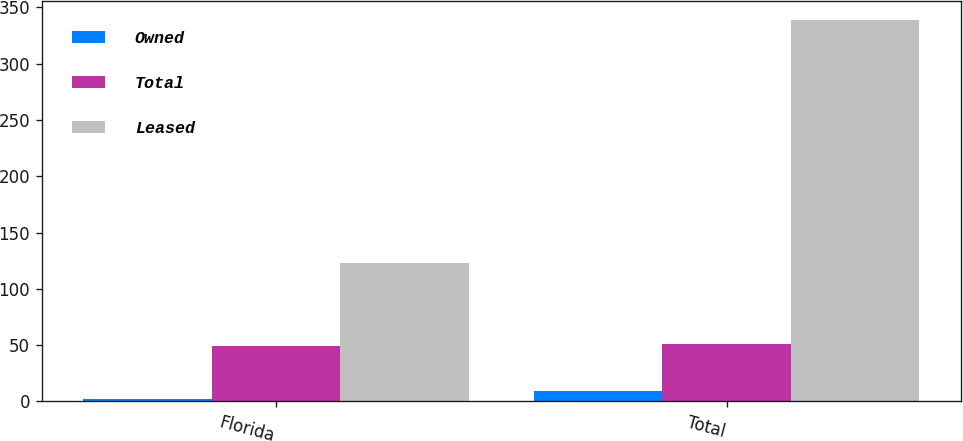Convert chart to OTSL. <chart><loc_0><loc_0><loc_500><loc_500><stacked_bar_chart><ecel><fcel>Florida<fcel>Total<nl><fcel>Owned<fcel>2<fcel>9<nl><fcel>Total<fcel>49<fcel>51<nl><fcel>Leased<fcel>123<fcel>339<nl></chart> 